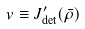<formula> <loc_0><loc_0><loc_500><loc_500>v \equiv J _ { \det } ^ { \prime } ( \bar { \rho } )</formula> 